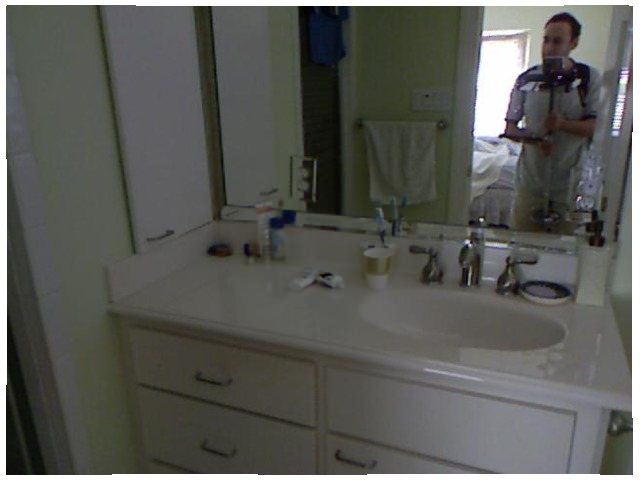<image>
Is there a man in the sink? No. The man is not contained within the sink. These objects have a different spatial relationship. 